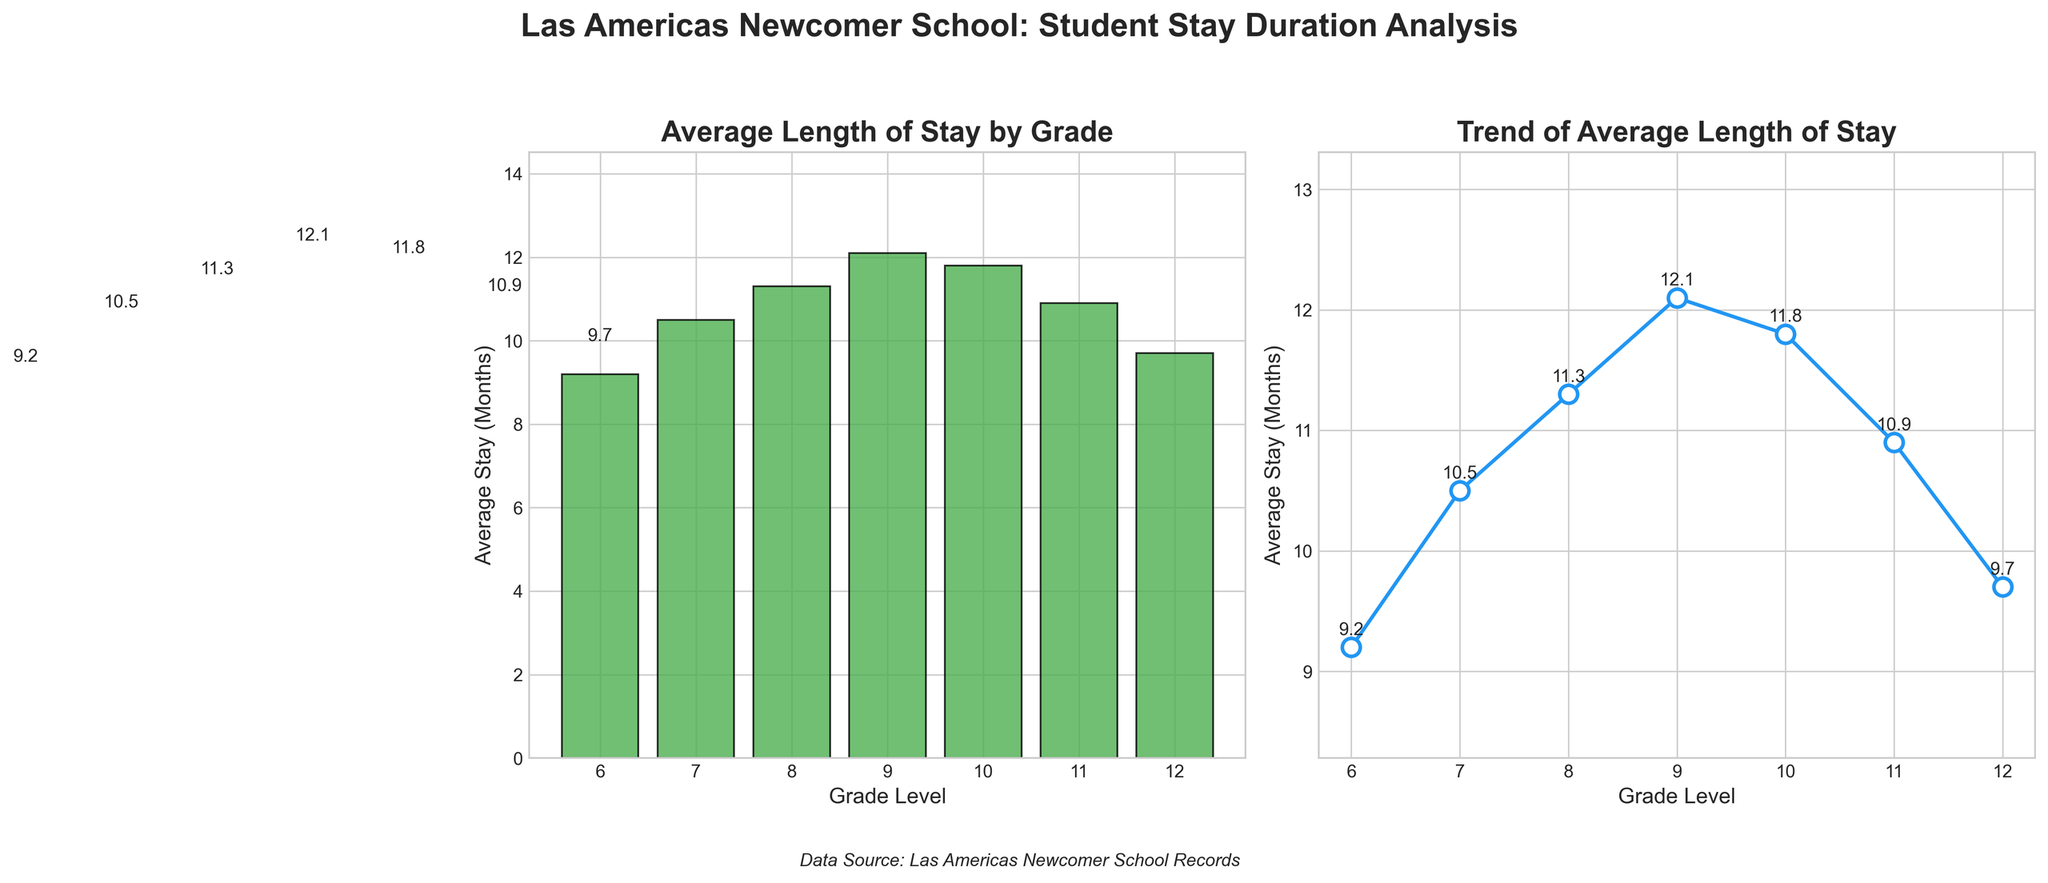What is the average length of stay for 9th graders? Look at the bar or line associated with the 9th grade, which shows the height or the point for the value 12.1 months.
Answer: 12.1 months Is the average length of stay greater for 8th graders or 12th graders? Compare the bars or points for 8th grade and 12th grade. The 8th grade has an average stay of 11.3 months, while the 12th grade has an average stay of 9.7 months.
Answer: 8th graders What is the difference in the average length of stay between 10th and 12th graders? Subtract the average stay for 12th graders (9.7 months) from the average stay for 10th graders (11.8 months). 11.8 - 9.7 = 2.1
Answer: 2.1 months Which grade has the longest average stay? Look for the highest bar or peak point on the plots. The 9th grade has the longest average stay of 12.1 months.
Answer: 9th grade Which grades have an average stay longer than 10 months? Identify bars or points that are above the 10-month mark. Grades 7, 8, 9, 10, and 11 have stays longer than 10 months.
Answer: Grades 7, 8, 9, 10, and 11 Is there any grade whose average stay is less than 10 months? Look for bars or points below the 10-month mark. Grades 6 and 12 have stays less than 10 months.
Answer: Grades 6 and 12 If a student stays an average length of time in 11th grade, how much longer do they stay compared to a student in 6th grade? Subtract the average stay for 6th grade (9.2 months) from the average stay for 11th grade (10.9 months). 10.9 - 9.2 = 1.7
Answer: 1.7 months What is the trend of the average length of stay from 6th grade to 9th grade? Observing the line plot, there is a generally increasing trend from 9.2 months in 6th grade to 12.1 months in 9th grade.
Answer: Increasing trend Between which consecutive grades is the biggest jump in average stay? Compare the difference between each consecutive grade. The biggest jump is between 6th grade (9.2 months) and 7th grade (10.5 months). 10.5 - 9.2 = 1.3
Answer: Between 6th and 7th grades What is the sum of the average stays for grades 6, 8, and 10? Add the average stays for grades 6 (9.2 months), 8 (11.3 months), and 10 (11.8 months). 9.2 + 11.3 + 11.8 = 32.3
Answer: 32.3 months 